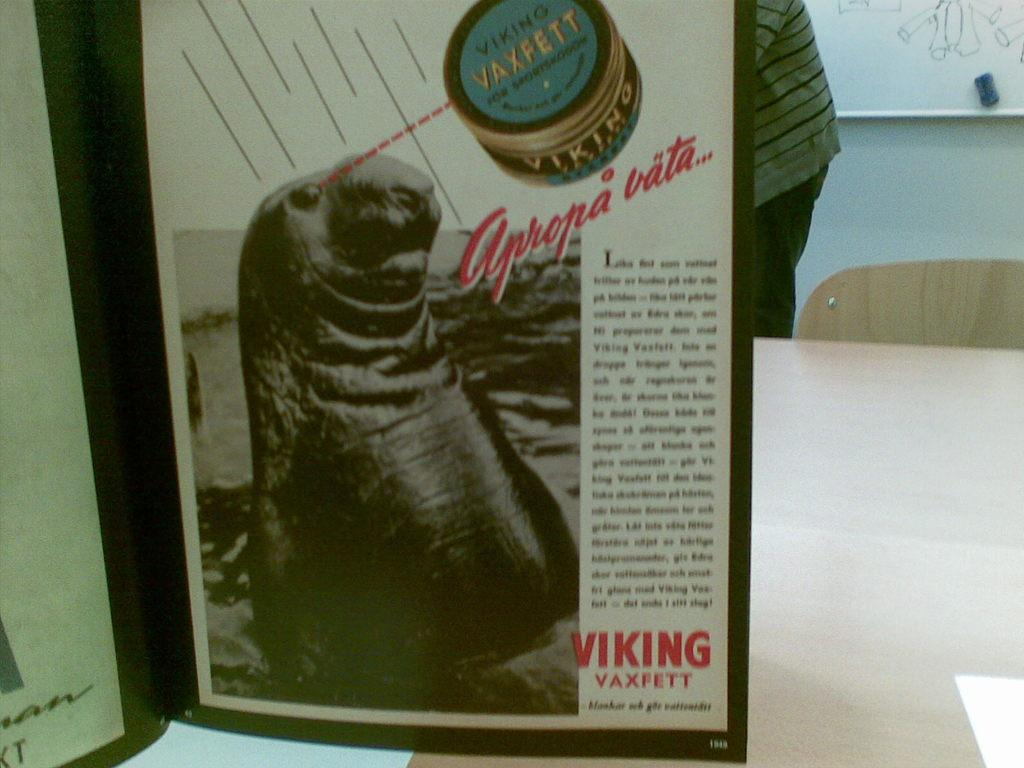<image>
Write a terse but informative summary of the picture. A magazine page from Viking Vaxfett features a photo of a seal. 